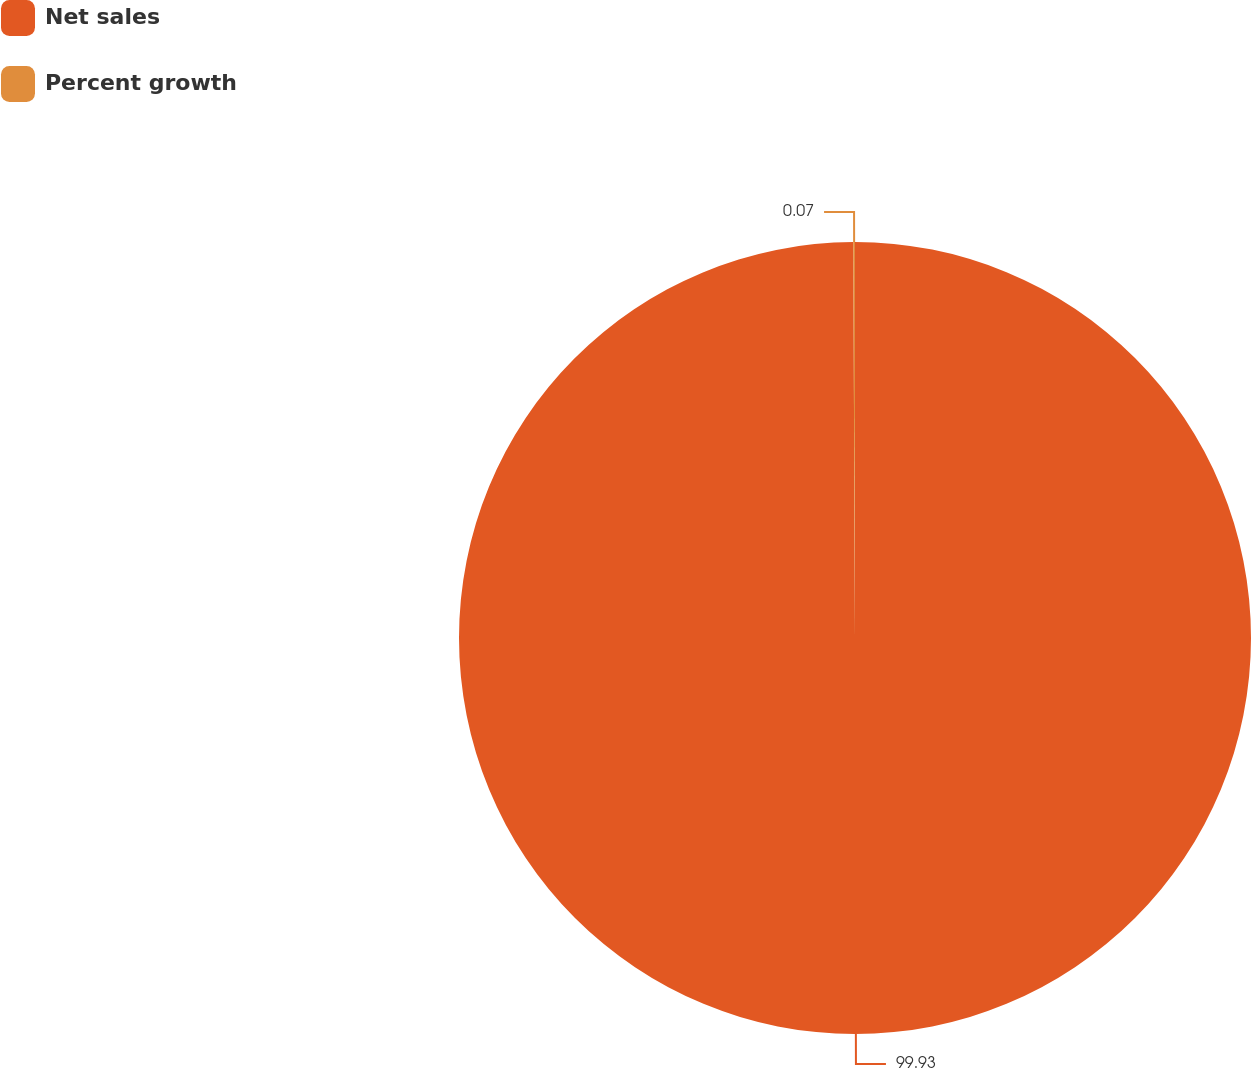Convert chart. <chart><loc_0><loc_0><loc_500><loc_500><pie_chart><fcel>Net sales<fcel>Percent growth<nl><fcel>99.93%<fcel>0.07%<nl></chart> 